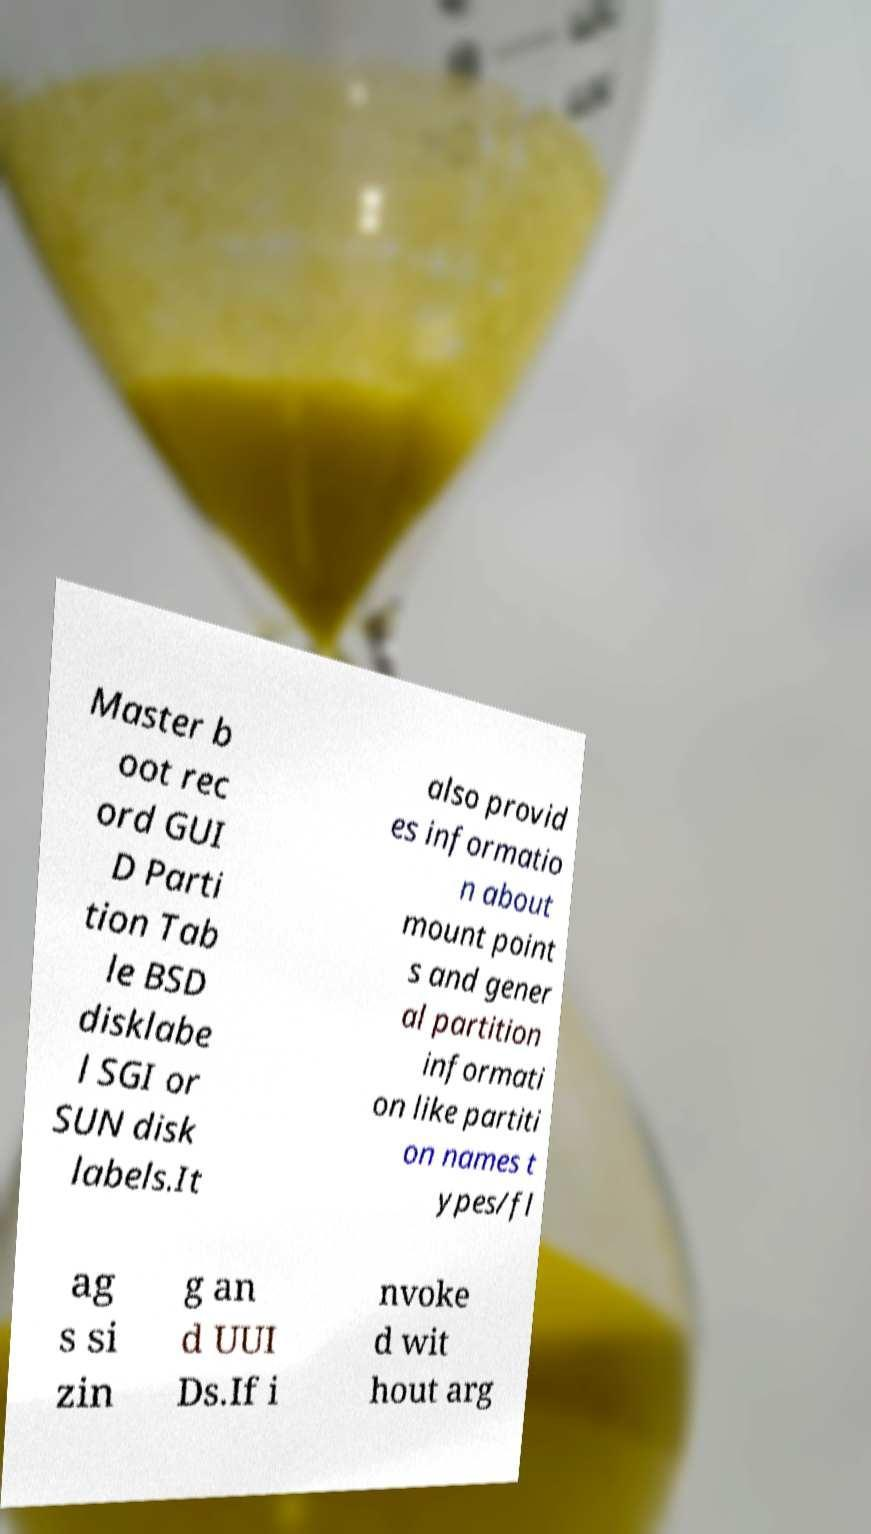What messages or text are displayed in this image? I need them in a readable, typed format. Master b oot rec ord GUI D Parti tion Tab le BSD disklabe l SGI or SUN disk labels.It also provid es informatio n about mount point s and gener al partition informati on like partiti on names t ypes/fl ag s si zin g an d UUI Ds.If i nvoke d wit hout arg 